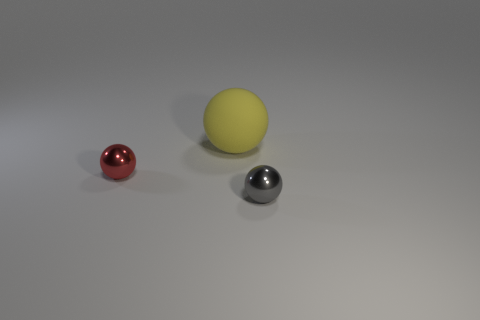Add 1 large brown rubber things. How many objects exist? 4 Subtract all small shiny balls. Subtract all red metal objects. How many objects are left? 0 Add 1 matte things. How many matte things are left? 2 Add 1 cyan things. How many cyan things exist? 1 Subtract 0 green balls. How many objects are left? 3 